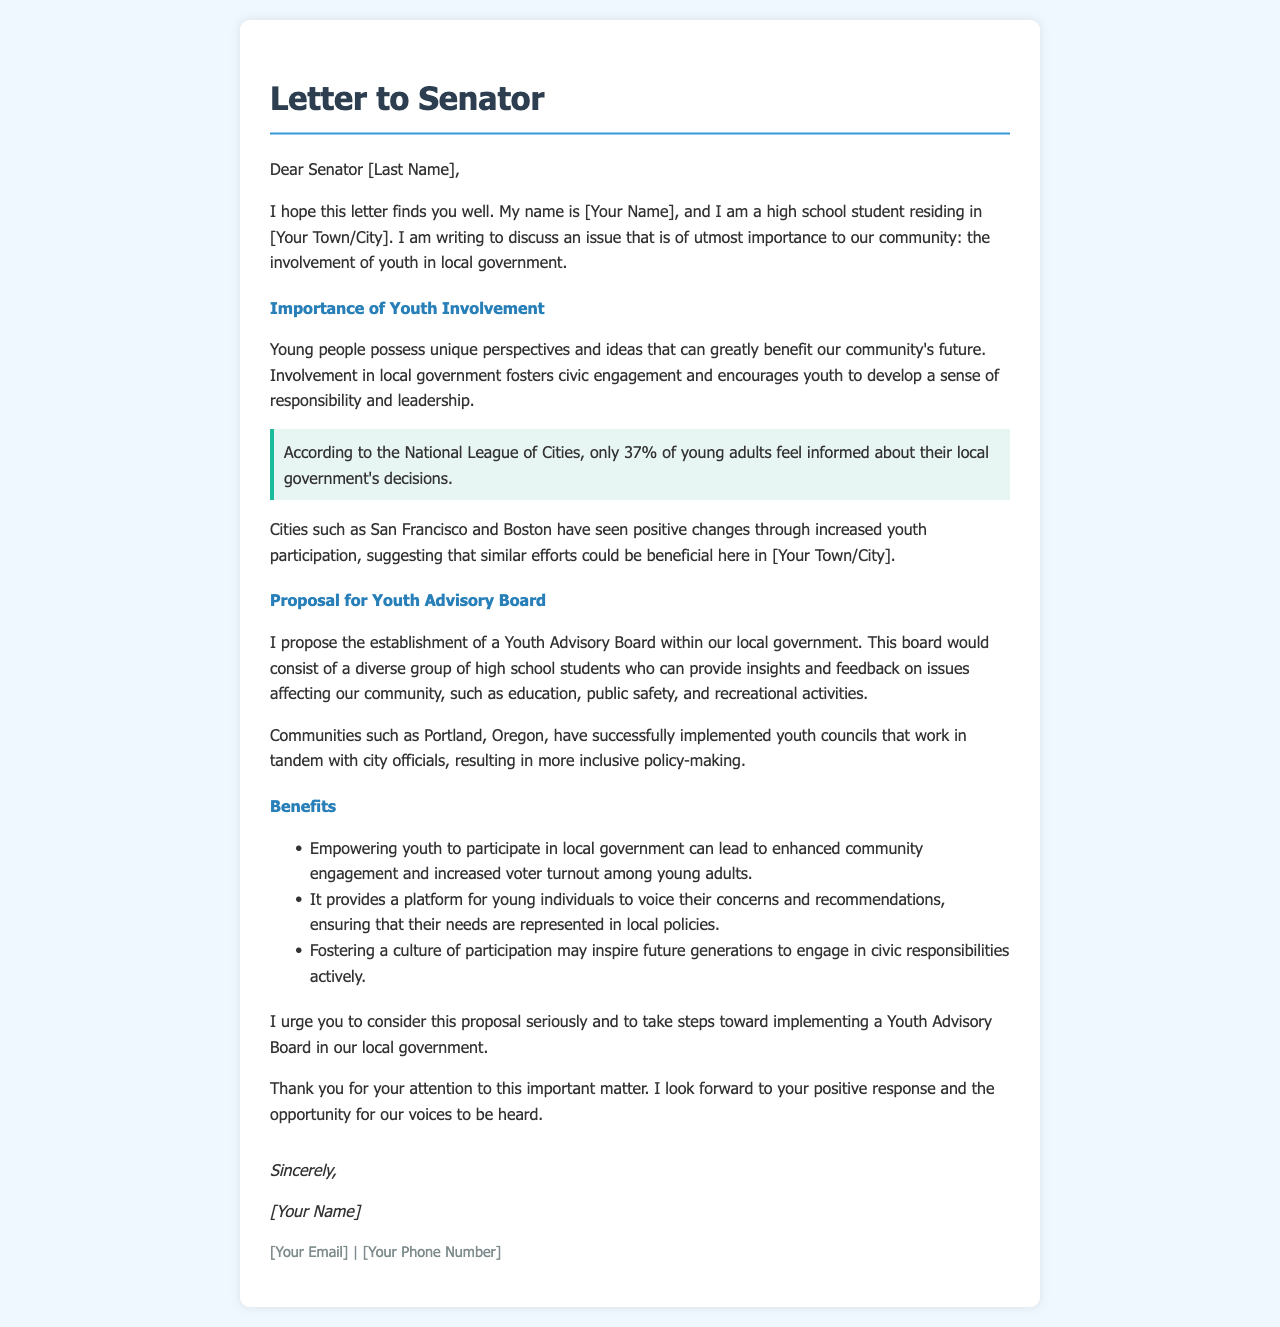What is the main purpose of the letter? The letter discusses the importance of youth involvement in local government and proposes the establishment of a Youth Advisory Board.
Answer: Importance of youth involvement Who is the author of the letter? The letter states that the author is a high school student named [Your Name].
Answer: [Your Name] What percentage of young adults feel informed about their local government's decisions? The letter mentions that only 37% of young adults feel informed about local government's decisions.
Answer: 37% What is the proposed name for the advisory group? The letter proposes the establishment of a Youth Advisory Board.
Answer: Youth Advisory Board What community is mentioned as having successfully implemented youth councils? The letter refers to Portland, Oregon, as a community that has successfully implemented youth councils.
Answer: Portland, Oregon What is one benefit of empowering youth mentioned in the document? The letter states one benefit is enhanced community engagement and increased voter turnout among young adults.
Answer: Enhanced community engagement What should the Youth Advisory Board consist of? The letter indicates that the board would consist of a diverse group of high school students.
Answer: Diverse group of high school students What closing remark does the author make? The author urges the senator to consider the proposal seriously regarding the Youth Advisory Board.
Answer: Consider this proposal seriously 